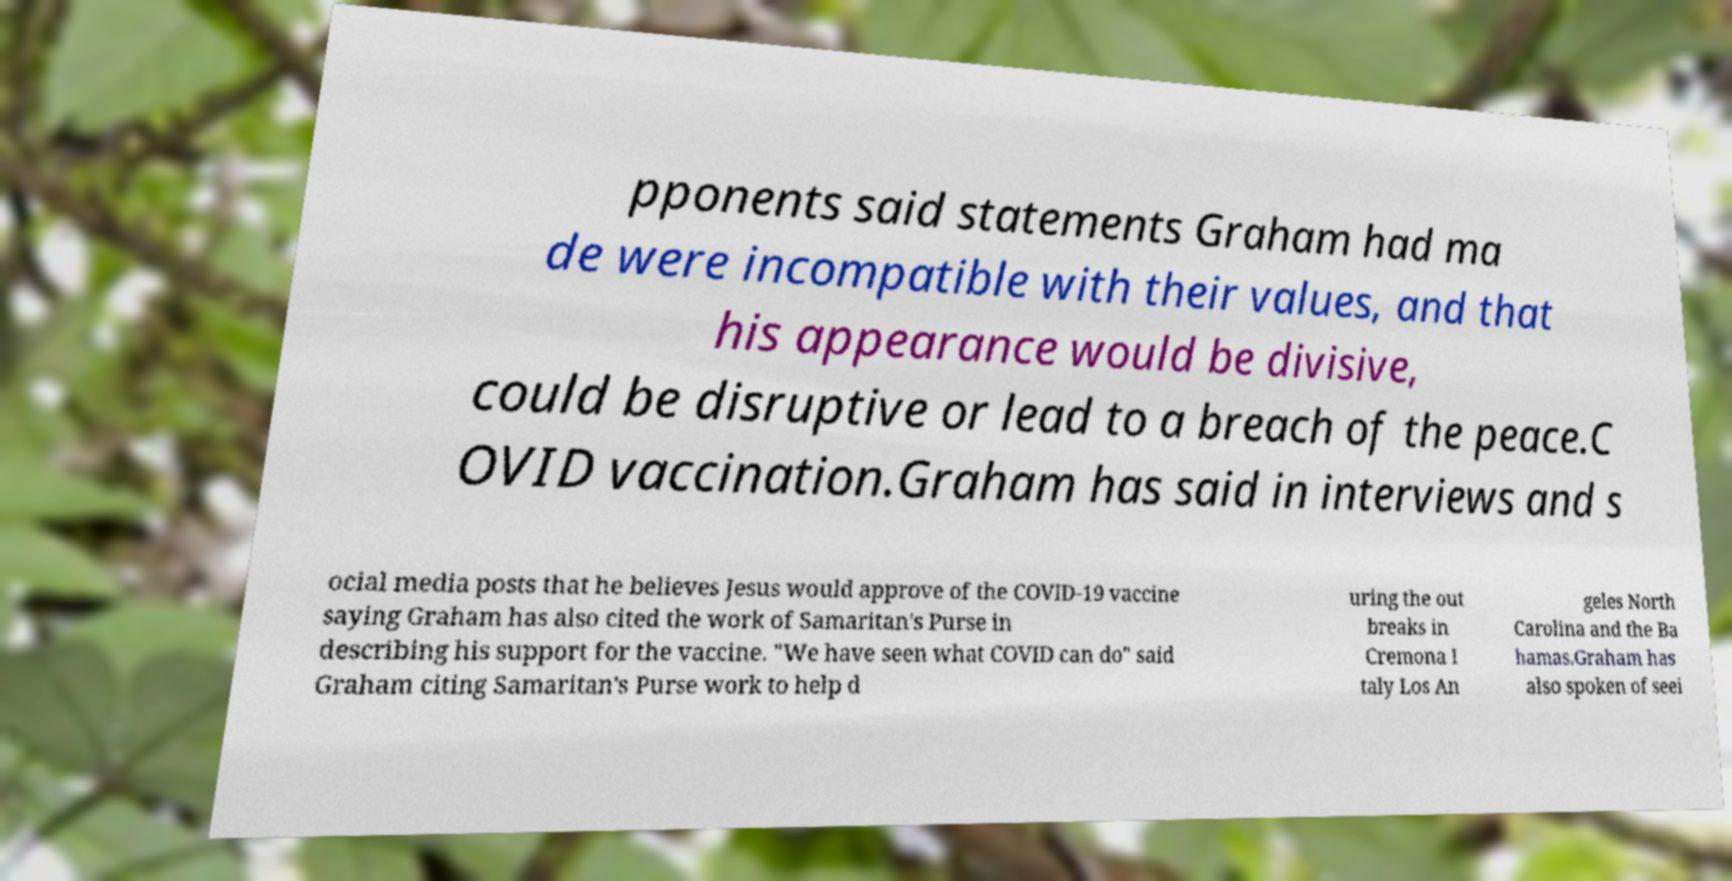I need the written content from this picture converted into text. Can you do that? pponents said statements Graham had ma de were incompatible with their values, and that his appearance would be divisive, could be disruptive or lead to a breach of the peace.C OVID vaccination.Graham has said in interviews and s ocial media posts that he believes Jesus would approve of the COVID-19 vaccine saying Graham has also cited the work of Samaritan's Purse in describing his support for the vaccine. "We have seen what COVID can do" said Graham citing Samaritan's Purse work to help d uring the out breaks in Cremona I taly Los An geles North Carolina and the Ba hamas.Graham has also spoken of seei 